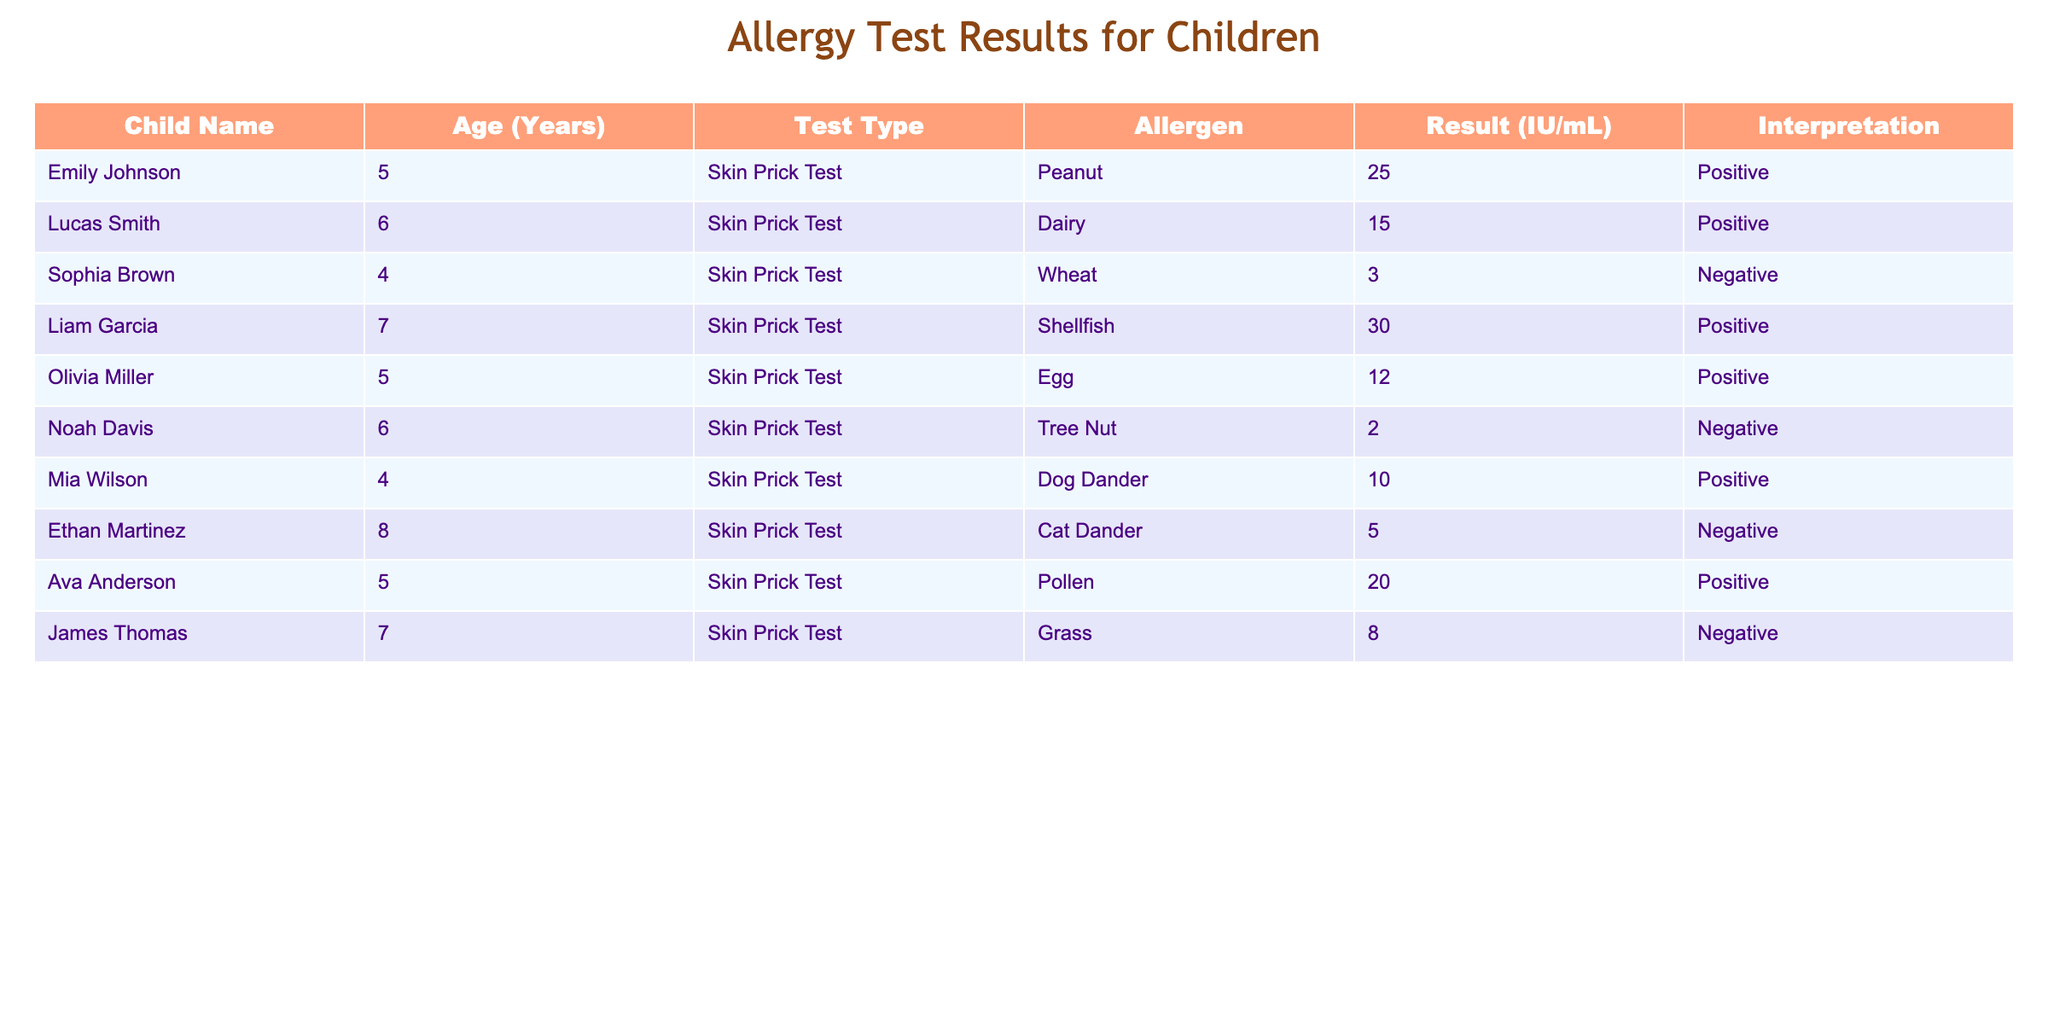What is the age of Liam Garcia? Liam Garcia is listed in the table with the age of 7 years.
Answer: 7 How many children tested positive for peanut allergy? Emily Johnson is the only child who tested positive for peanut allergy, which is directly mentioned in the results.
Answer: 1 What is the average allergen result for all the children tested? Adding all the results: (25 + 15 + 3 + 30 + 12 + 2 + 10 + 5 + 20 + 8) = 130, and there are 10 children, so the average result is 130 / 10 = 13.
Answer: 13 Did any child test negative for dairy allergy? The table indicates that Lucas Smith tested positive for dairy and shows no child tested negative for dairy, so the answer is no.
Answer: No Which allergen had the highest individual result? The table shows that Liam Garcia had the highest result of 30 IU/mL for shellfish allergy, which is the maximum among all results listed.
Answer: Shellfish How many children tested positive for more than one allergen? Looking through the table, no child is listed as testing positive for more than one allergen, so the answer is zero.
Answer: 0 Is there any child who tested negative for both tree nut and cat dander allergies? Noah Davis tested negative for tree nut, and Ethan Martinez tested negative for cat dander. Both children tested negative for their respective allergens, confirming there are children who meet this condition.
Answer: Yes What is the total number of positive tests reported for egg, wheat, and pollen allergies? The positive test results for each of these allergens are: egg (12), wheat (3), and pollen (20). Adding them provides a total of 12 + 3 + 20 = 35 positive tests.
Answer: 35 How many children are allergic to dog dander? According to the table, Mia Wilson is the only child who tested positive for dog dander allergy.
Answer: 1 